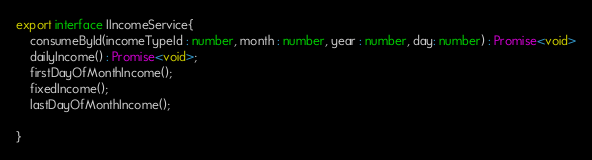Convert code to text. <code><loc_0><loc_0><loc_500><loc_500><_TypeScript_>export interface IIncomeService{
    consumeById(incomeTypeId : number, month : number, year : number, day: number) : Promise<void>
    dailyIncome() : Promise<void>;
    firstDayOfMonthIncome();
    fixedIncome();
    lastDayOfMonthIncome();

}</code> 